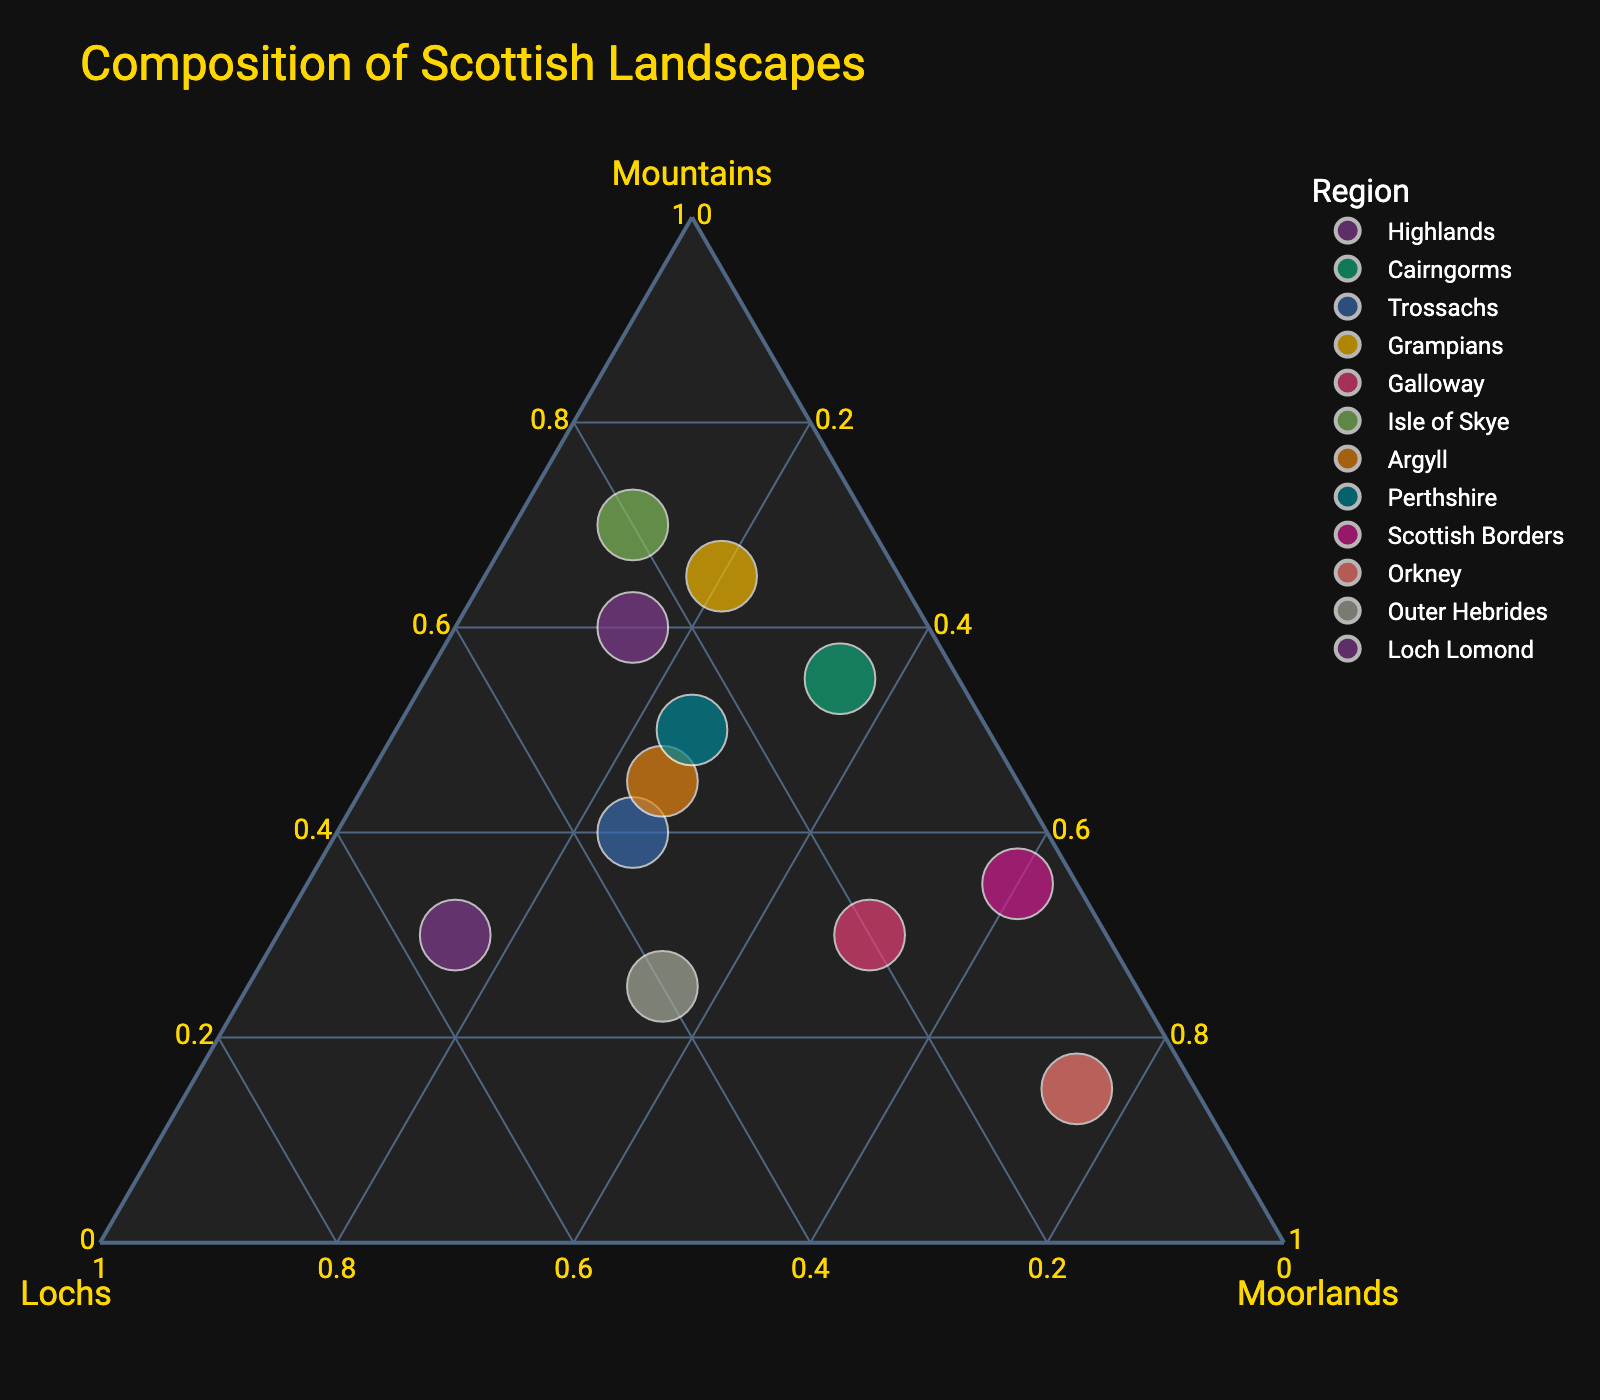What is the title of the chart? The title is usually located at the top of the chart and serves to inform viewers about the content of the visualization. In this case, the title should clearly state what the ternary plot is about.
Answer: Composition of Scottish Landscapes How many regions are represented in the plot? To determine the number of regions, check the data points labeled by region names. Each point represents a different region. Counting these labels will give the number of regions.
Answer: 12 Which region has the highest percentage of mountains? Look for the data point that is closest to the "Mountains" vertex on the ternary plot. This point will represent the region with the highest percentage of mountains.
Answer: Isle of Skye Which two regions have the closest percentage composition of lochs? Identify the regions that have data points positioned nearest to each other along the lochs axis. This will indicate the closest percentage composition of lochs.
Answer: Trossachs and Loch Lomond Compare the percentage of moorlands between Galloway and Cairngorms. Which one has a higher percentage? To compare these regions, locate their data points and observe their proximity to the "Moorlands" vertex. The closer point has the higher percentage.
Answer: Galloway What is the average percentage composition of moorlands across all regions? Sum the percentage values of moorlands for all regions and divide by the number of regions (12). Calculate for (15 + 35 + 25 + 20 + 50 + 10 + 25 + 25 + 60 + 75 + 35 + 15) / 12 = 36.67 (rounded to two decimal places).
Answer: 36.67% Which region has a more balanced composition of mountains, lochs, and moorlands? A balanced composition would have data points near the center of the plot (equidistant from all three vertices). Identify the region closest to the centroid of the ternary plot.
Answer: Perthshire How does Argyll's composition compare with that of Highlands? Compare the relative positions of both data points. Argyll is more to the center compared to Highlands, which means Argyll has a more balanced composition, whereas Highlands has more mountains.
Answer: Argyll is more balanced Which region has the highest percentage of lochs? Identify the data point closest to the "Lochs" vertex on the ternary plot. That point represents the region with the highest percentage of lochs.
Answer: Loch Lomond What is the combined percentage of mountains, lochs, and moorlands in Outer Hebrides? Add the percentage values of mountains, lochs, and moorlands for Outer Hebrides (25 + 40 + 35). The sum yields the total composition percentage.
Answer: 100% 